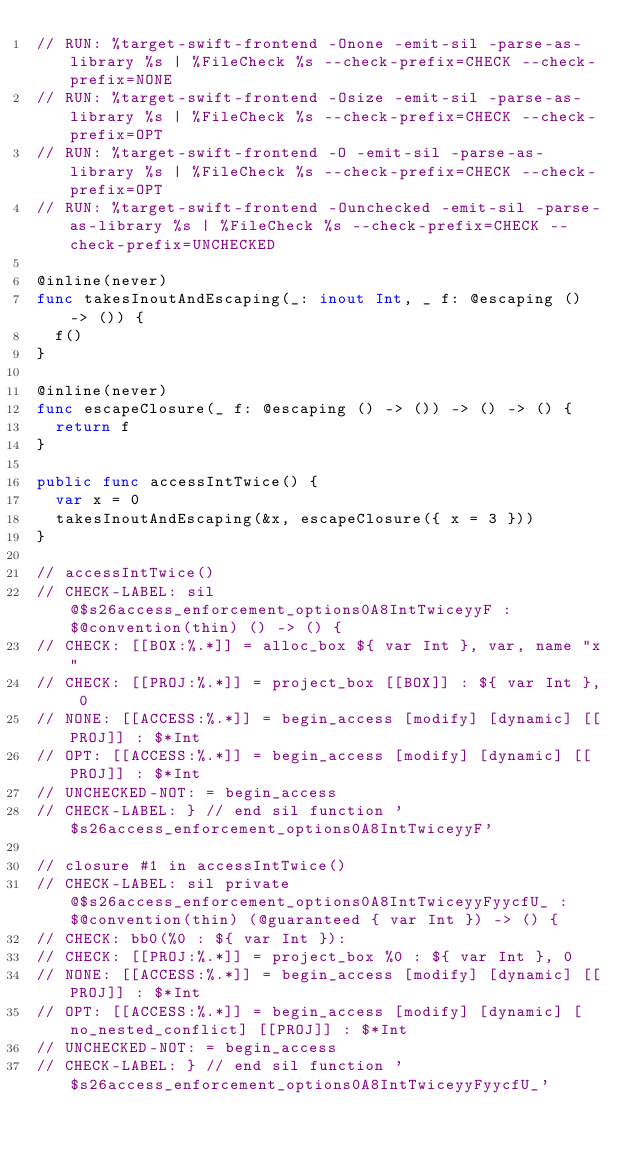Convert code to text. <code><loc_0><loc_0><loc_500><loc_500><_Swift_>// RUN: %target-swift-frontend -Onone -emit-sil -parse-as-library %s | %FileCheck %s --check-prefix=CHECK --check-prefix=NONE
// RUN: %target-swift-frontend -Osize -emit-sil -parse-as-library %s | %FileCheck %s --check-prefix=CHECK --check-prefix=OPT
// RUN: %target-swift-frontend -O -emit-sil -parse-as-library %s | %FileCheck %s --check-prefix=CHECK --check-prefix=OPT
// RUN: %target-swift-frontend -Ounchecked -emit-sil -parse-as-library %s | %FileCheck %s --check-prefix=CHECK --check-prefix=UNCHECKED

@inline(never)
func takesInoutAndEscaping(_: inout Int, _ f: @escaping () -> ()) {
  f()
}

@inline(never)
func escapeClosure(_ f: @escaping () -> ()) -> () -> () {
  return f
}

public func accessIntTwice() {
  var x = 0
  takesInoutAndEscaping(&x, escapeClosure({ x = 3 }))
}

// accessIntTwice()
// CHECK-LABEL: sil @$s26access_enforcement_options0A8IntTwiceyyF : $@convention(thin) () -> () {
// CHECK: [[BOX:%.*]] = alloc_box ${ var Int }, var, name "x"
// CHECK: [[PROJ:%.*]] = project_box [[BOX]] : ${ var Int }, 0
// NONE: [[ACCESS:%.*]] = begin_access [modify] [dynamic] [[PROJ]] : $*Int
// OPT: [[ACCESS:%.*]] = begin_access [modify] [dynamic] [[PROJ]] : $*Int
// UNCHECKED-NOT: = begin_access
// CHECK-LABEL: } // end sil function '$s26access_enforcement_options0A8IntTwiceyyF'

// closure #1 in accessIntTwice()
// CHECK-LABEL: sil private @$s26access_enforcement_options0A8IntTwiceyyFyycfU_ : $@convention(thin) (@guaranteed { var Int }) -> () {
// CHECK: bb0(%0 : ${ var Int }):
// CHECK: [[PROJ:%.*]] = project_box %0 : ${ var Int }, 0
// NONE: [[ACCESS:%.*]] = begin_access [modify] [dynamic] [[PROJ]] : $*Int
// OPT: [[ACCESS:%.*]] = begin_access [modify] [dynamic] [no_nested_conflict] [[PROJ]] : $*Int
// UNCHECKED-NOT: = begin_access
// CHECK-LABEL: } // end sil function '$s26access_enforcement_options0A8IntTwiceyyFyycfU_'
</code> 